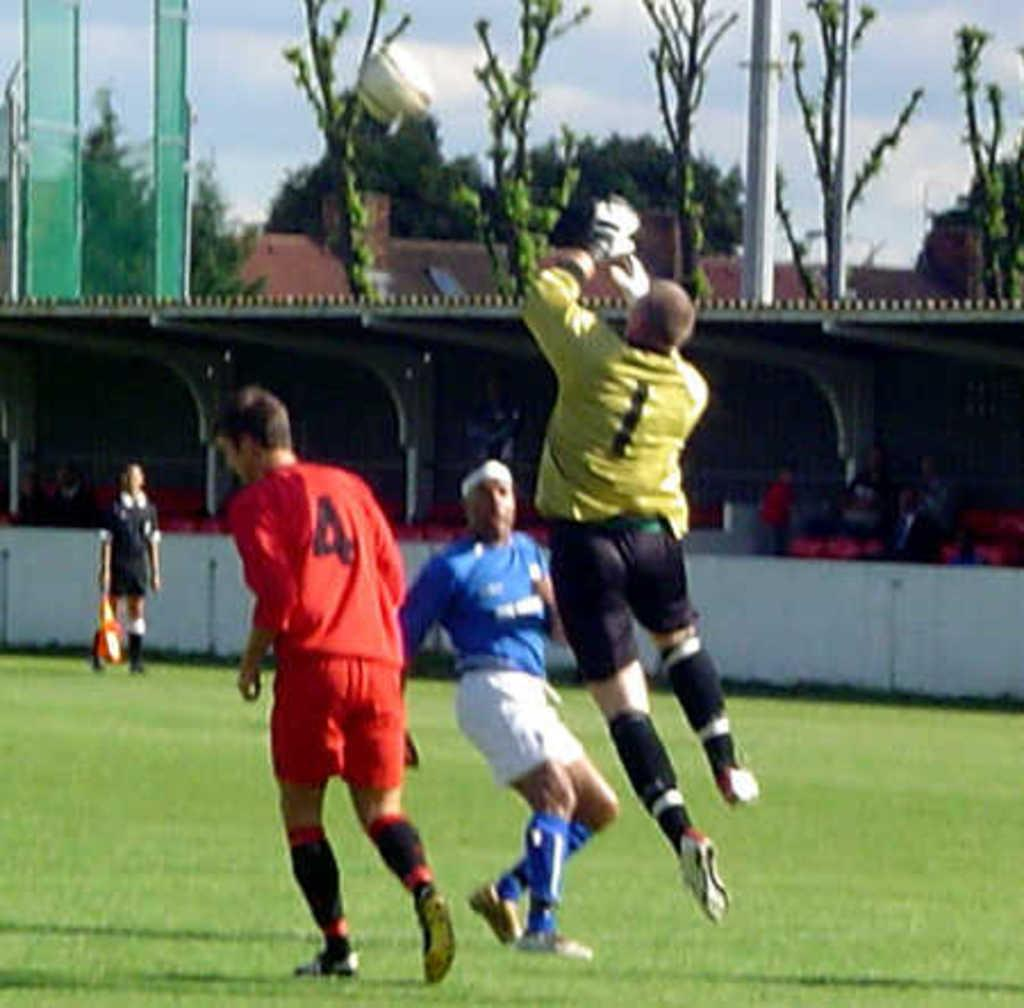<image>
Provide a brief description of the given image. A man with a yellow jersey with a 1 on it jumps in the air to stop a ball. 